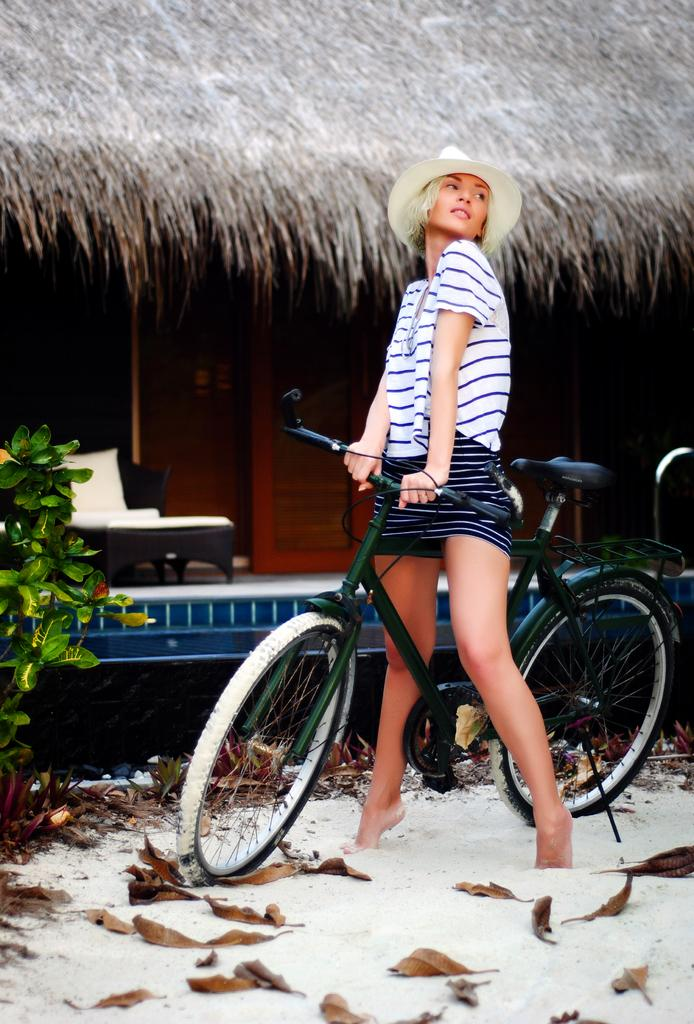What is the person in the image doing? The person is standing in the image and holding a bicycle. What type of surface is the person standing on? The ground appears to be sand. What can be seen in the background of the image? There is a bed in the background of the image. Are there any plants visible in the image? Yes, there is a plant in the image. What type of truck can be seen driving through the sand in the image? There is no truck present in the image; it only features a person holding a bicycle. How many units of the plant are visible in the image? The question is unclear, as "units" is not a term typically used to describe plants. However, there is only one plant visible in the image. 